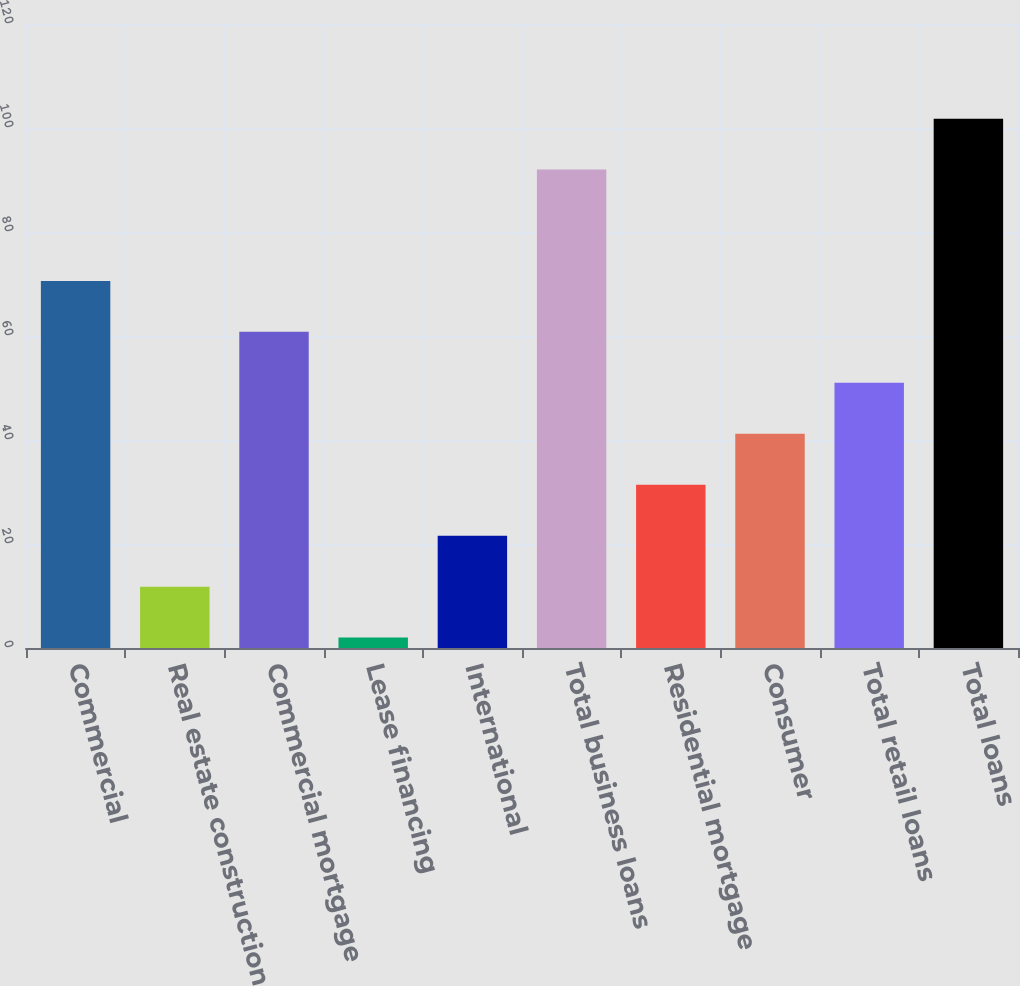Convert chart. <chart><loc_0><loc_0><loc_500><loc_500><bar_chart><fcel>Commercial<fcel>Real estate construction<fcel>Commercial mortgage<fcel>Lease financing<fcel>International<fcel>Total business loans<fcel>Residential mortgage<fcel>Consumer<fcel>Total retail loans<fcel>Total loans<nl><fcel>70.6<fcel>11.8<fcel>60.8<fcel>2<fcel>21.6<fcel>92<fcel>31.4<fcel>41.2<fcel>51<fcel>101.8<nl></chart> 